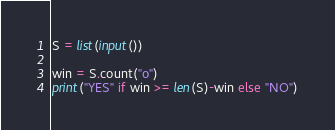<code> <loc_0><loc_0><loc_500><loc_500><_Python_>S = list(input())

win = S.count("o")
print("YES" if win >= len(S)-win else "NO")</code> 